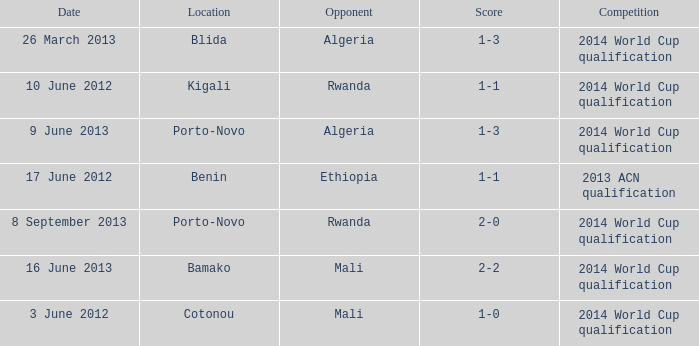In bamako, what competitive event can be found? 2014 World Cup qualification. Can you give me this table as a dict? {'header': ['Date', 'Location', 'Opponent', 'Score', 'Competition'], 'rows': [['26 March 2013', 'Blida', 'Algeria', '1-3', '2014 World Cup qualification'], ['10 June 2012', 'Kigali', 'Rwanda', '1-1', '2014 World Cup qualification'], ['9 June 2013', 'Porto-Novo', 'Algeria', '1-3', '2014 World Cup qualification'], ['17 June 2012', 'Benin', 'Ethiopia', '1-1', '2013 ACN qualification'], ['8 September 2013', 'Porto-Novo', 'Rwanda', '2-0', '2014 World Cup qualification'], ['16 June 2013', 'Bamako', 'Mali', '2-2', '2014 World Cup qualification'], ['3 June 2012', 'Cotonou', 'Mali', '1-0', '2014 World Cup qualification']]} 